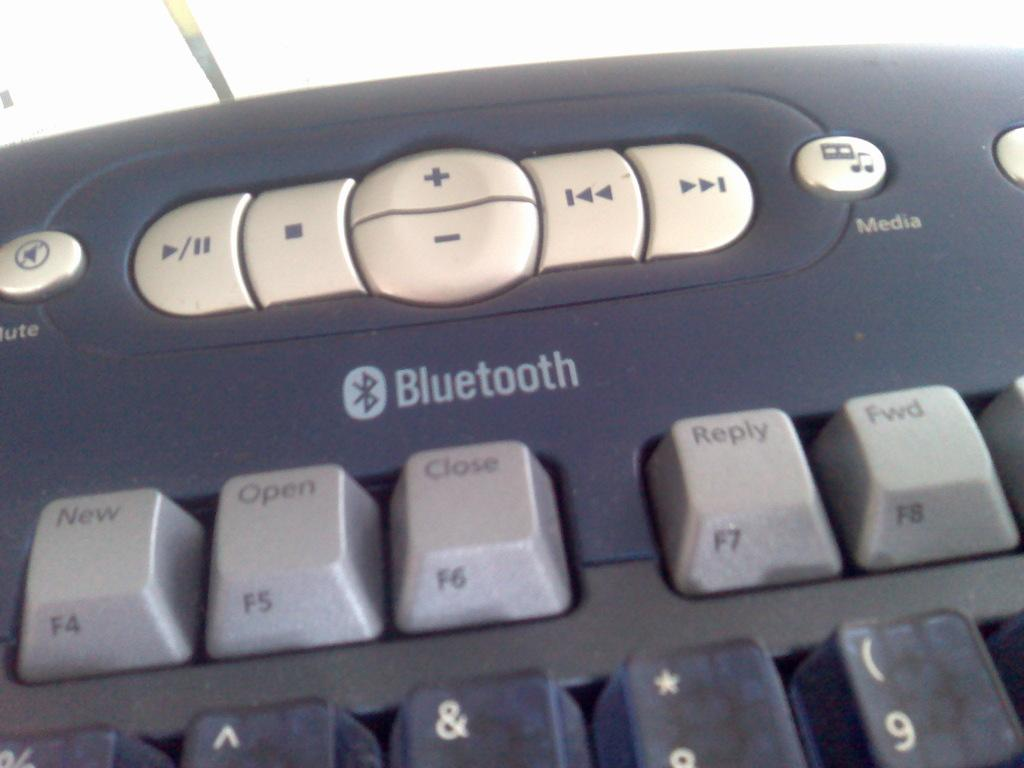<image>
Share a concise interpretation of the image provided. The part of a keyboard that has the Bluetooth controls. 